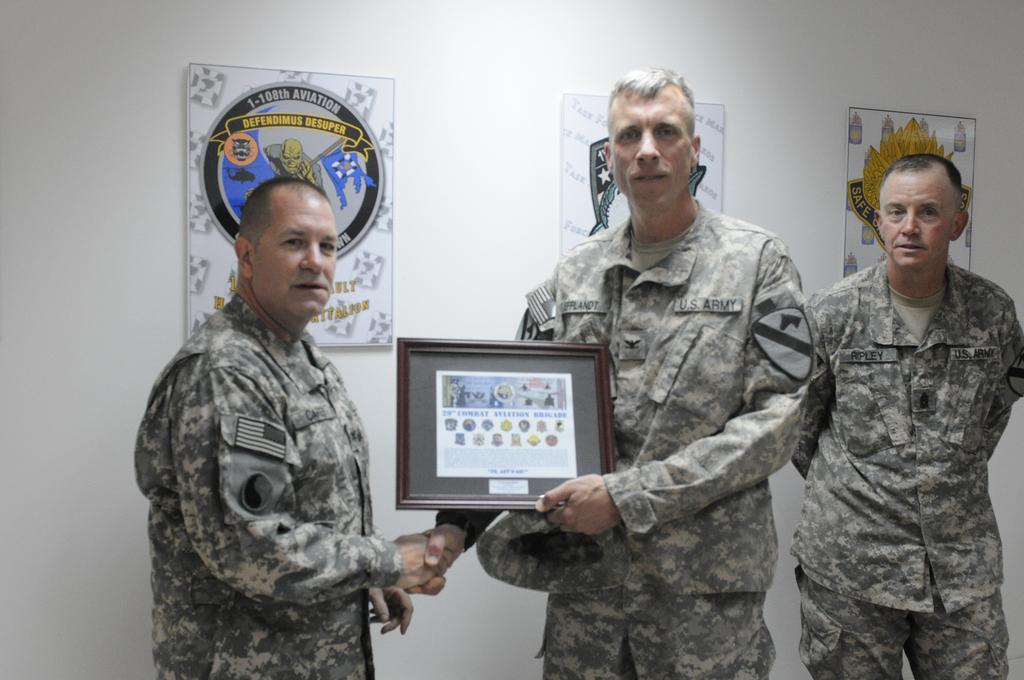How many people are in the image? There are three people in the image. What are the people wearing? The people are wearing army dresses. What is the person in the middle holding? The person in the middle is holding a frame. What can be seen in the background of the image? There is a wall in the background of the image. What is on the wall in the background? There are posters on the wall. What type of gun can be seen in the image? There is no gun present in the image. Is the image taken on a street? The provided facts do not mention the location or setting of the image, so it cannot be determined if it was taken on a street. 